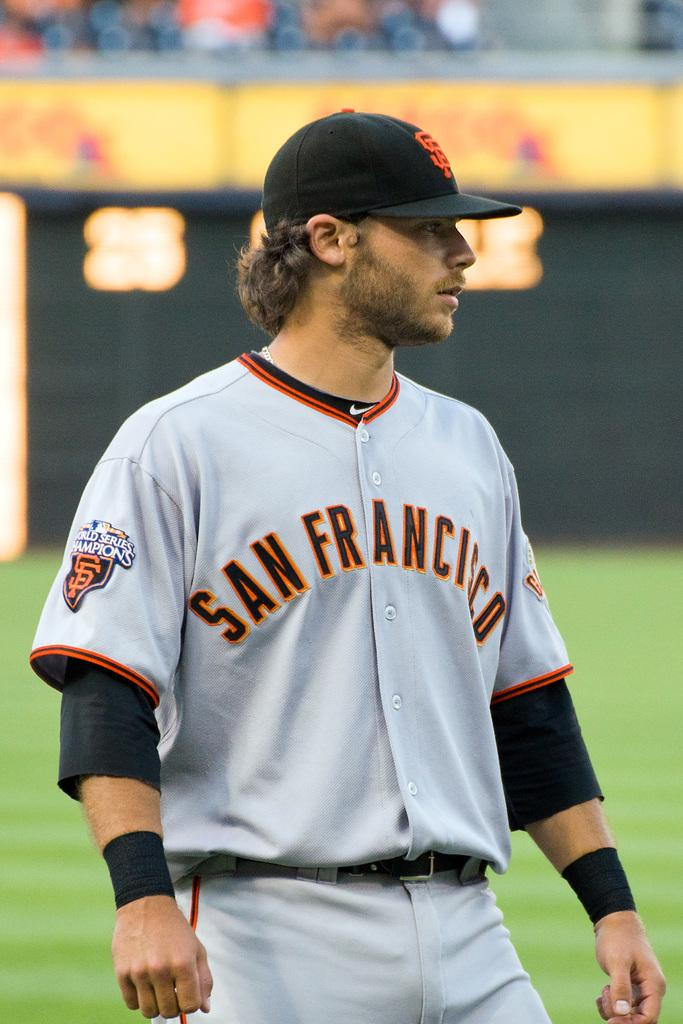<image>
Present a compact description of the photo's key features. Baseball player in a gray uniform with orange and black letters that state San Francisco. 